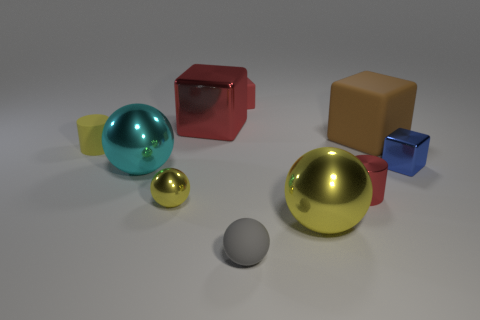Is there anything else that has the same color as the matte sphere?
Keep it short and to the point. No. What is the shape of the big matte object?
Provide a succinct answer. Cube. What shape is the yellow thing that is the same material as the gray sphere?
Give a very brief answer. Cylinder. Does the tiny red rubber thing behind the tiny metal cylinder have the same shape as the blue thing?
Offer a terse response. Yes. There is a rubber object to the right of the tiny gray rubber object; what shape is it?
Your answer should be very brief. Cube. The large object that is the same color as the small rubber cylinder is what shape?
Provide a succinct answer. Sphere. How many other matte things have the same size as the blue thing?
Your answer should be very brief. 3. The large metal block has what color?
Ensure brevity in your answer.  Red. Is the color of the small metal cylinder the same as the large metallic thing that is behind the cyan shiny sphere?
Provide a short and direct response. Yes. The red block that is the same material as the gray ball is what size?
Provide a succinct answer. Small. 